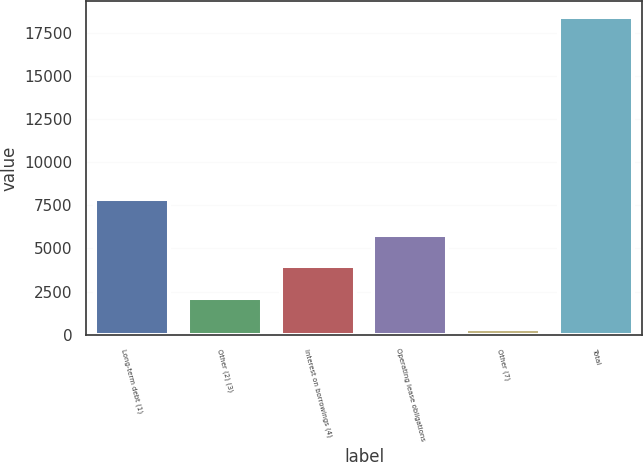Convert chart to OTSL. <chart><loc_0><loc_0><loc_500><loc_500><bar_chart><fcel>Long-term debt (1)<fcel>Other (2) (3)<fcel>Interest on borrowings (4)<fcel>Operating lease obligations<fcel>Other (7)<fcel>Total<nl><fcel>7880<fcel>2145.7<fcel>3953.4<fcel>5761.1<fcel>338<fcel>18415<nl></chart> 